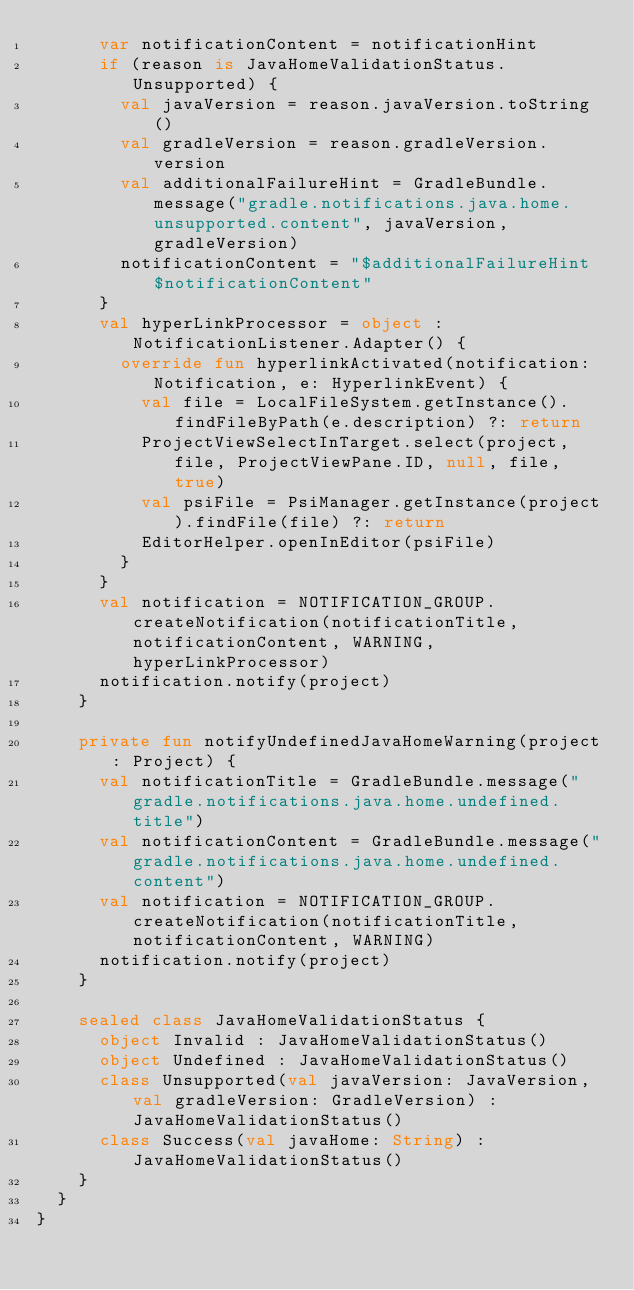Convert code to text. <code><loc_0><loc_0><loc_500><loc_500><_Kotlin_>      var notificationContent = notificationHint
      if (reason is JavaHomeValidationStatus.Unsupported) {
        val javaVersion = reason.javaVersion.toString()
        val gradleVersion = reason.gradleVersion.version
        val additionalFailureHint = GradleBundle.message("gradle.notifications.java.home.unsupported.content", javaVersion, gradleVersion)
        notificationContent = "$additionalFailureHint $notificationContent"
      }
      val hyperLinkProcessor = object : NotificationListener.Adapter() {
        override fun hyperlinkActivated(notification: Notification, e: HyperlinkEvent) {
          val file = LocalFileSystem.getInstance().findFileByPath(e.description) ?: return
          ProjectViewSelectInTarget.select(project, file, ProjectViewPane.ID, null, file, true)
          val psiFile = PsiManager.getInstance(project).findFile(file) ?: return
          EditorHelper.openInEditor(psiFile)
        }
      }
      val notification = NOTIFICATION_GROUP.createNotification(notificationTitle, notificationContent, WARNING, hyperLinkProcessor)
      notification.notify(project)
    }

    private fun notifyUndefinedJavaHomeWarning(project: Project) {
      val notificationTitle = GradleBundle.message("gradle.notifications.java.home.undefined.title")
      val notificationContent = GradleBundle.message("gradle.notifications.java.home.undefined.content")
      val notification = NOTIFICATION_GROUP.createNotification(notificationTitle, notificationContent, WARNING)
      notification.notify(project)
    }

    sealed class JavaHomeValidationStatus {
      object Invalid : JavaHomeValidationStatus()
      object Undefined : JavaHomeValidationStatus()
      class Unsupported(val javaVersion: JavaVersion, val gradleVersion: GradleVersion) : JavaHomeValidationStatus()
      class Success(val javaHome: String) : JavaHomeValidationStatus()
    }
  }
}</code> 